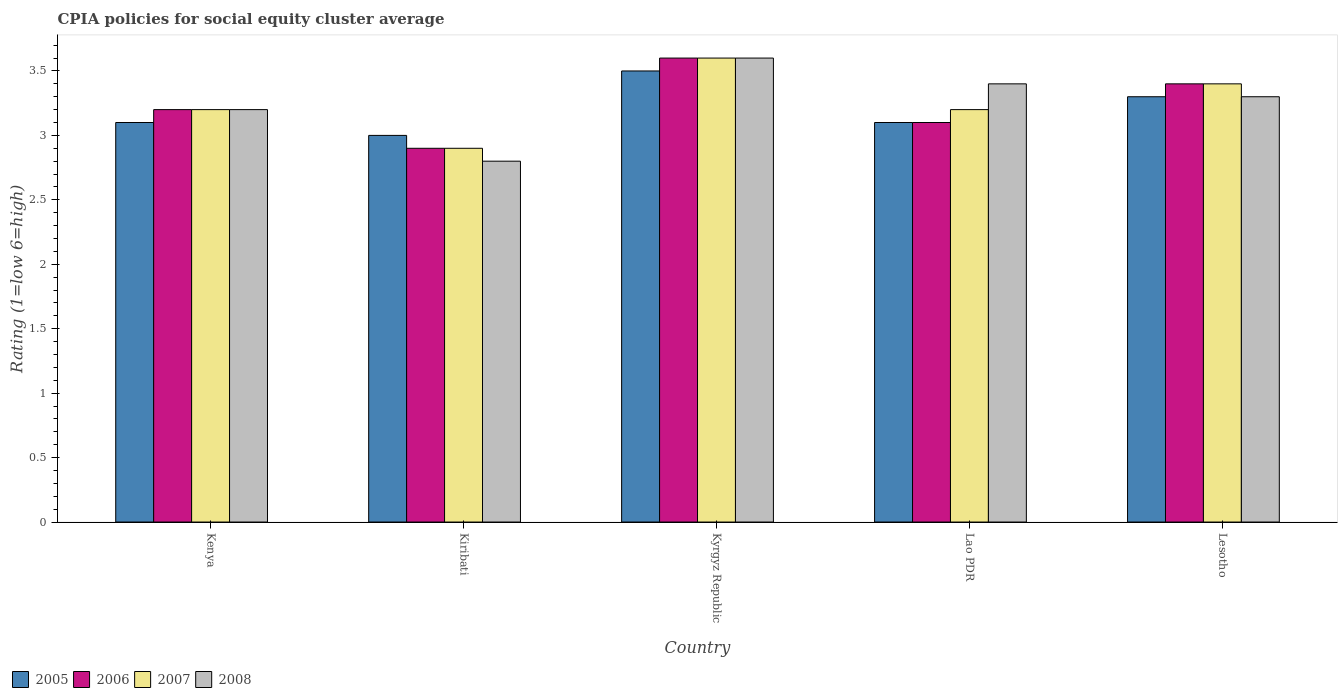How many groups of bars are there?
Make the answer very short. 5. How many bars are there on the 2nd tick from the left?
Provide a short and direct response. 4. How many bars are there on the 2nd tick from the right?
Keep it short and to the point. 4. What is the label of the 4th group of bars from the left?
Provide a short and direct response. Lao PDR. Across all countries, what is the maximum CPIA rating in 2008?
Make the answer very short. 3.6. In which country was the CPIA rating in 2007 maximum?
Provide a short and direct response. Kyrgyz Republic. In which country was the CPIA rating in 2007 minimum?
Provide a short and direct response. Kiribati. What is the difference between the CPIA rating in 2006 in Kiribati and that in Lesotho?
Your response must be concise. -0.5. What is the difference between the CPIA rating in 2005 in Kiribati and the CPIA rating in 2008 in Kenya?
Provide a succinct answer. -0.2. What is the average CPIA rating in 2006 per country?
Your answer should be compact. 3.24. What is the difference between the CPIA rating of/in 2007 and CPIA rating of/in 2008 in Lao PDR?
Provide a succinct answer. -0.2. In how many countries, is the CPIA rating in 2008 greater than 3.5?
Provide a short and direct response. 1. What is the ratio of the CPIA rating in 2007 in Kiribati to that in Kyrgyz Republic?
Give a very brief answer. 0.81. Is the CPIA rating in 2006 in Kyrgyz Republic less than that in Lao PDR?
Ensure brevity in your answer.  No. What is the difference between the highest and the second highest CPIA rating in 2005?
Provide a short and direct response. -0.2. What is the difference between the highest and the lowest CPIA rating in 2007?
Your answer should be very brief. 0.7. In how many countries, is the CPIA rating in 2008 greater than the average CPIA rating in 2008 taken over all countries?
Ensure brevity in your answer.  3. Is the sum of the CPIA rating in 2007 in Kenya and Kiribati greater than the maximum CPIA rating in 2006 across all countries?
Provide a short and direct response. Yes. What does the 1st bar from the left in Lesotho represents?
Provide a succinct answer. 2005. Is it the case that in every country, the sum of the CPIA rating in 2008 and CPIA rating in 2005 is greater than the CPIA rating in 2006?
Keep it short and to the point. Yes. How many bars are there?
Offer a very short reply. 20. What is the difference between two consecutive major ticks on the Y-axis?
Keep it short and to the point. 0.5. What is the title of the graph?
Make the answer very short. CPIA policies for social equity cluster average. Does "1972" appear as one of the legend labels in the graph?
Offer a terse response. No. What is the label or title of the X-axis?
Your answer should be compact. Country. What is the Rating (1=low 6=high) in 2005 in Kenya?
Provide a short and direct response. 3.1. What is the Rating (1=low 6=high) in 2008 in Kenya?
Give a very brief answer. 3.2. What is the Rating (1=low 6=high) of 2007 in Kiribati?
Provide a short and direct response. 2.9. What is the Rating (1=low 6=high) of 2008 in Kiribati?
Keep it short and to the point. 2.8. What is the Rating (1=low 6=high) in 2005 in Kyrgyz Republic?
Provide a short and direct response. 3.5. What is the Rating (1=low 6=high) in 2007 in Kyrgyz Republic?
Your answer should be compact. 3.6. What is the Rating (1=low 6=high) in 2008 in Kyrgyz Republic?
Your answer should be compact. 3.6. What is the Rating (1=low 6=high) in 2005 in Lao PDR?
Offer a very short reply. 3.1. What is the Rating (1=low 6=high) of 2008 in Lao PDR?
Your response must be concise. 3.4. What is the Rating (1=low 6=high) of 2005 in Lesotho?
Your response must be concise. 3.3. What is the Rating (1=low 6=high) of 2006 in Lesotho?
Provide a short and direct response. 3.4. Across all countries, what is the maximum Rating (1=low 6=high) in 2005?
Your answer should be very brief. 3.5. Across all countries, what is the maximum Rating (1=low 6=high) in 2006?
Provide a succinct answer. 3.6. Across all countries, what is the maximum Rating (1=low 6=high) in 2007?
Provide a short and direct response. 3.6. Across all countries, what is the maximum Rating (1=low 6=high) of 2008?
Provide a succinct answer. 3.6. Across all countries, what is the minimum Rating (1=low 6=high) of 2006?
Offer a very short reply. 2.9. Across all countries, what is the minimum Rating (1=low 6=high) of 2007?
Make the answer very short. 2.9. Across all countries, what is the minimum Rating (1=low 6=high) of 2008?
Offer a very short reply. 2.8. What is the total Rating (1=low 6=high) of 2005 in the graph?
Make the answer very short. 16. What is the total Rating (1=low 6=high) in 2006 in the graph?
Your answer should be compact. 16.2. What is the difference between the Rating (1=low 6=high) in 2005 in Kenya and that in Kiribati?
Ensure brevity in your answer.  0.1. What is the difference between the Rating (1=low 6=high) of 2006 in Kenya and that in Kiribati?
Provide a succinct answer. 0.3. What is the difference between the Rating (1=low 6=high) of 2007 in Kenya and that in Kiribati?
Make the answer very short. 0.3. What is the difference between the Rating (1=low 6=high) in 2008 in Kenya and that in Kiribati?
Give a very brief answer. 0.4. What is the difference between the Rating (1=low 6=high) in 2005 in Kenya and that in Kyrgyz Republic?
Give a very brief answer. -0.4. What is the difference between the Rating (1=low 6=high) in 2007 in Kenya and that in Kyrgyz Republic?
Provide a short and direct response. -0.4. What is the difference between the Rating (1=low 6=high) of 2005 in Kenya and that in Lao PDR?
Keep it short and to the point. 0. What is the difference between the Rating (1=low 6=high) of 2007 in Kenya and that in Lao PDR?
Offer a very short reply. 0. What is the difference between the Rating (1=low 6=high) in 2005 in Kenya and that in Lesotho?
Your answer should be very brief. -0.2. What is the difference between the Rating (1=low 6=high) in 2008 in Kenya and that in Lesotho?
Your response must be concise. -0.1. What is the difference between the Rating (1=low 6=high) in 2005 in Kiribati and that in Kyrgyz Republic?
Your response must be concise. -0.5. What is the difference between the Rating (1=low 6=high) in 2007 in Kiribati and that in Kyrgyz Republic?
Provide a short and direct response. -0.7. What is the difference between the Rating (1=low 6=high) of 2008 in Kiribati and that in Kyrgyz Republic?
Provide a succinct answer. -0.8. What is the difference between the Rating (1=low 6=high) of 2007 in Kiribati and that in Lao PDR?
Keep it short and to the point. -0.3. What is the difference between the Rating (1=low 6=high) in 2005 in Kiribati and that in Lesotho?
Ensure brevity in your answer.  -0.3. What is the difference between the Rating (1=low 6=high) of 2008 in Kiribati and that in Lesotho?
Offer a very short reply. -0.5. What is the difference between the Rating (1=low 6=high) of 2008 in Kyrgyz Republic and that in Lao PDR?
Your answer should be very brief. 0.2. What is the difference between the Rating (1=low 6=high) in 2005 in Kyrgyz Republic and that in Lesotho?
Provide a succinct answer. 0.2. What is the difference between the Rating (1=low 6=high) of 2007 in Kyrgyz Republic and that in Lesotho?
Your response must be concise. 0.2. What is the difference between the Rating (1=low 6=high) of 2005 in Lao PDR and that in Lesotho?
Provide a short and direct response. -0.2. What is the difference between the Rating (1=low 6=high) in 2006 in Lao PDR and that in Lesotho?
Ensure brevity in your answer.  -0.3. What is the difference between the Rating (1=low 6=high) in 2007 in Lao PDR and that in Lesotho?
Offer a very short reply. -0.2. What is the difference between the Rating (1=low 6=high) in 2008 in Lao PDR and that in Lesotho?
Keep it short and to the point. 0.1. What is the difference between the Rating (1=low 6=high) in 2005 in Kenya and the Rating (1=low 6=high) in 2006 in Kiribati?
Your answer should be very brief. 0.2. What is the difference between the Rating (1=low 6=high) of 2005 in Kenya and the Rating (1=low 6=high) of 2006 in Kyrgyz Republic?
Ensure brevity in your answer.  -0.5. What is the difference between the Rating (1=low 6=high) in 2005 in Kenya and the Rating (1=low 6=high) in 2007 in Kyrgyz Republic?
Give a very brief answer. -0.5. What is the difference between the Rating (1=low 6=high) in 2005 in Kenya and the Rating (1=low 6=high) in 2008 in Kyrgyz Republic?
Offer a very short reply. -0.5. What is the difference between the Rating (1=low 6=high) of 2006 in Kenya and the Rating (1=low 6=high) of 2008 in Kyrgyz Republic?
Keep it short and to the point. -0.4. What is the difference between the Rating (1=low 6=high) in 2005 in Kenya and the Rating (1=low 6=high) in 2006 in Lao PDR?
Offer a very short reply. 0. What is the difference between the Rating (1=low 6=high) in 2005 in Kenya and the Rating (1=low 6=high) in 2007 in Lao PDR?
Offer a terse response. -0.1. What is the difference between the Rating (1=low 6=high) of 2006 in Kenya and the Rating (1=low 6=high) of 2007 in Lao PDR?
Give a very brief answer. 0. What is the difference between the Rating (1=low 6=high) of 2005 in Kenya and the Rating (1=low 6=high) of 2007 in Lesotho?
Offer a very short reply. -0.3. What is the difference between the Rating (1=low 6=high) in 2005 in Kenya and the Rating (1=low 6=high) in 2008 in Lesotho?
Your answer should be compact. -0.2. What is the difference between the Rating (1=low 6=high) in 2007 in Kenya and the Rating (1=low 6=high) in 2008 in Lesotho?
Keep it short and to the point. -0.1. What is the difference between the Rating (1=low 6=high) in 2006 in Kiribati and the Rating (1=low 6=high) in 2007 in Kyrgyz Republic?
Provide a short and direct response. -0.7. What is the difference between the Rating (1=low 6=high) in 2007 in Kiribati and the Rating (1=low 6=high) in 2008 in Kyrgyz Republic?
Keep it short and to the point. -0.7. What is the difference between the Rating (1=low 6=high) of 2005 in Kiribati and the Rating (1=low 6=high) of 2006 in Lao PDR?
Offer a very short reply. -0.1. What is the difference between the Rating (1=low 6=high) in 2006 in Kiribati and the Rating (1=low 6=high) in 2007 in Lao PDR?
Ensure brevity in your answer.  -0.3. What is the difference between the Rating (1=low 6=high) in 2006 in Kiribati and the Rating (1=low 6=high) in 2008 in Lao PDR?
Offer a terse response. -0.5. What is the difference between the Rating (1=low 6=high) of 2007 in Kiribati and the Rating (1=low 6=high) of 2008 in Lao PDR?
Provide a succinct answer. -0.5. What is the difference between the Rating (1=low 6=high) in 2005 in Kiribati and the Rating (1=low 6=high) in 2008 in Lesotho?
Provide a short and direct response. -0.3. What is the difference between the Rating (1=low 6=high) of 2006 in Kiribati and the Rating (1=low 6=high) of 2007 in Lesotho?
Offer a terse response. -0.5. What is the difference between the Rating (1=low 6=high) of 2006 in Kiribati and the Rating (1=low 6=high) of 2008 in Lesotho?
Provide a succinct answer. -0.4. What is the difference between the Rating (1=low 6=high) in 2005 in Kyrgyz Republic and the Rating (1=low 6=high) in 2006 in Lao PDR?
Provide a short and direct response. 0.4. What is the difference between the Rating (1=low 6=high) of 2005 in Kyrgyz Republic and the Rating (1=low 6=high) of 2007 in Lao PDR?
Make the answer very short. 0.3. What is the difference between the Rating (1=low 6=high) of 2006 in Kyrgyz Republic and the Rating (1=low 6=high) of 2007 in Lao PDR?
Make the answer very short. 0.4. What is the difference between the Rating (1=low 6=high) in 2006 in Kyrgyz Republic and the Rating (1=low 6=high) in 2008 in Lao PDR?
Ensure brevity in your answer.  0.2. What is the difference between the Rating (1=low 6=high) in 2007 in Kyrgyz Republic and the Rating (1=low 6=high) in 2008 in Lao PDR?
Your answer should be compact. 0.2. What is the difference between the Rating (1=low 6=high) of 2005 in Kyrgyz Republic and the Rating (1=low 6=high) of 2006 in Lesotho?
Ensure brevity in your answer.  0.1. What is the difference between the Rating (1=low 6=high) of 2005 in Kyrgyz Republic and the Rating (1=low 6=high) of 2007 in Lesotho?
Ensure brevity in your answer.  0.1. What is the difference between the Rating (1=low 6=high) in 2006 in Kyrgyz Republic and the Rating (1=low 6=high) in 2007 in Lesotho?
Your response must be concise. 0.2. What is the difference between the Rating (1=low 6=high) of 2005 in Lao PDR and the Rating (1=low 6=high) of 2006 in Lesotho?
Provide a succinct answer. -0.3. What is the difference between the Rating (1=low 6=high) in 2005 in Lao PDR and the Rating (1=low 6=high) in 2008 in Lesotho?
Give a very brief answer. -0.2. What is the difference between the Rating (1=low 6=high) of 2006 in Lao PDR and the Rating (1=low 6=high) of 2007 in Lesotho?
Give a very brief answer. -0.3. What is the difference between the Rating (1=low 6=high) of 2006 in Lao PDR and the Rating (1=low 6=high) of 2008 in Lesotho?
Provide a succinct answer. -0.2. What is the average Rating (1=low 6=high) in 2005 per country?
Offer a very short reply. 3.2. What is the average Rating (1=low 6=high) of 2006 per country?
Provide a short and direct response. 3.24. What is the average Rating (1=low 6=high) of 2007 per country?
Make the answer very short. 3.26. What is the average Rating (1=low 6=high) of 2008 per country?
Your response must be concise. 3.26. What is the difference between the Rating (1=low 6=high) in 2005 and Rating (1=low 6=high) in 2006 in Kenya?
Provide a short and direct response. -0.1. What is the difference between the Rating (1=low 6=high) in 2005 and Rating (1=low 6=high) in 2008 in Kenya?
Give a very brief answer. -0.1. What is the difference between the Rating (1=low 6=high) of 2006 and Rating (1=low 6=high) of 2007 in Kenya?
Provide a short and direct response. 0. What is the difference between the Rating (1=low 6=high) of 2005 and Rating (1=low 6=high) of 2006 in Kiribati?
Your response must be concise. 0.1. What is the difference between the Rating (1=low 6=high) in 2005 and Rating (1=low 6=high) in 2008 in Kiribati?
Your response must be concise. 0.2. What is the difference between the Rating (1=low 6=high) in 2005 and Rating (1=low 6=high) in 2006 in Kyrgyz Republic?
Your answer should be very brief. -0.1. What is the difference between the Rating (1=low 6=high) of 2005 and Rating (1=low 6=high) of 2008 in Kyrgyz Republic?
Give a very brief answer. -0.1. What is the difference between the Rating (1=low 6=high) of 2006 and Rating (1=low 6=high) of 2007 in Kyrgyz Republic?
Offer a terse response. 0. What is the difference between the Rating (1=low 6=high) of 2006 and Rating (1=low 6=high) of 2007 in Lao PDR?
Your answer should be compact. -0.1. What is the difference between the Rating (1=low 6=high) of 2006 and Rating (1=low 6=high) of 2008 in Lao PDR?
Provide a short and direct response. -0.3. What is the difference between the Rating (1=low 6=high) of 2005 and Rating (1=low 6=high) of 2006 in Lesotho?
Offer a very short reply. -0.1. What is the difference between the Rating (1=low 6=high) of 2005 and Rating (1=low 6=high) of 2008 in Lesotho?
Offer a very short reply. 0. What is the difference between the Rating (1=low 6=high) in 2006 and Rating (1=low 6=high) in 2008 in Lesotho?
Provide a short and direct response. 0.1. What is the ratio of the Rating (1=low 6=high) in 2005 in Kenya to that in Kiribati?
Your answer should be very brief. 1.03. What is the ratio of the Rating (1=low 6=high) in 2006 in Kenya to that in Kiribati?
Your answer should be very brief. 1.1. What is the ratio of the Rating (1=low 6=high) of 2007 in Kenya to that in Kiribati?
Your answer should be compact. 1.1. What is the ratio of the Rating (1=low 6=high) of 2005 in Kenya to that in Kyrgyz Republic?
Your answer should be compact. 0.89. What is the ratio of the Rating (1=low 6=high) in 2006 in Kenya to that in Kyrgyz Republic?
Provide a succinct answer. 0.89. What is the ratio of the Rating (1=low 6=high) of 2006 in Kenya to that in Lao PDR?
Your answer should be compact. 1.03. What is the ratio of the Rating (1=low 6=high) in 2005 in Kenya to that in Lesotho?
Make the answer very short. 0.94. What is the ratio of the Rating (1=low 6=high) of 2006 in Kenya to that in Lesotho?
Offer a very short reply. 0.94. What is the ratio of the Rating (1=low 6=high) in 2008 in Kenya to that in Lesotho?
Provide a succinct answer. 0.97. What is the ratio of the Rating (1=low 6=high) of 2005 in Kiribati to that in Kyrgyz Republic?
Your answer should be compact. 0.86. What is the ratio of the Rating (1=low 6=high) in 2006 in Kiribati to that in Kyrgyz Republic?
Provide a short and direct response. 0.81. What is the ratio of the Rating (1=low 6=high) of 2007 in Kiribati to that in Kyrgyz Republic?
Keep it short and to the point. 0.81. What is the ratio of the Rating (1=low 6=high) of 2006 in Kiribati to that in Lao PDR?
Provide a short and direct response. 0.94. What is the ratio of the Rating (1=low 6=high) of 2007 in Kiribati to that in Lao PDR?
Your answer should be compact. 0.91. What is the ratio of the Rating (1=low 6=high) of 2008 in Kiribati to that in Lao PDR?
Your answer should be very brief. 0.82. What is the ratio of the Rating (1=low 6=high) of 2006 in Kiribati to that in Lesotho?
Provide a short and direct response. 0.85. What is the ratio of the Rating (1=low 6=high) of 2007 in Kiribati to that in Lesotho?
Offer a terse response. 0.85. What is the ratio of the Rating (1=low 6=high) of 2008 in Kiribati to that in Lesotho?
Ensure brevity in your answer.  0.85. What is the ratio of the Rating (1=low 6=high) of 2005 in Kyrgyz Republic to that in Lao PDR?
Provide a short and direct response. 1.13. What is the ratio of the Rating (1=low 6=high) in 2006 in Kyrgyz Republic to that in Lao PDR?
Give a very brief answer. 1.16. What is the ratio of the Rating (1=low 6=high) of 2007 in Kyrgyz Republic to that in Lao PDR?
Give a very brief answer. 1.12. What is the ratio of the Rating (1=low 6=high) in 2008 in Kyrgyz Republic to that in Lao PDR?
Provide a short and direct response. 1.06. What is the ratio of the Rating (1=low 6=high) of 2005 in Kyrgyz Republic to that in Lesotho?
Keep it short and to the point. 1.06. What is the ratio of the Rating (1=low 6=high) in 2006 in Kyrgyz Republic to that in Lesotho?
Make the answer very short. 1.06. What is the ratio of the Rating (1=low 6=high) in 2007 in Kyrgyz Republic to that in Lesotho?
Your response must be concise. 1.06. What is the ratio of the Rating (1=low 6=high) in 2005 in Lao PDR to that in Lesotho?
Make the answer very short. 0.94. What is the ratio of the Rating (1=low 6=high) of 2006 in Lao PDR to that in Lesotho?
Give a very brief answer. 0.91. What is the ratio of the Rating (1=low 6=high) of 2008 in Lao PDR to that in Lesotho?
Offer a very short reply. 1.03. What is the difference between the highest and the second highest Rating (1=low 6=high) of 2006?
Ensure brevity in your answer.  0.2. What is the difference between the highest and the second highest Rating (1=low 6=high) in 2007?
Your response must be concise. 0.2. What is the difference between the highest and the second highest Rating (1=low 6=high) in 2008?
Make the answer very short. 0.2. What is the difference between the highest and the lowest Rating (1=low 6=high) of 2005?
Provide a succinct answer. 0.5. What is the difference between the highest and the lowest Rating (1=low 6=high) in 2006?
Provide a short and direct response. 0.7. What is the difference between the highest and the lowest Rating (1=low 6=high) in 2007?
Ensure brevity in your answer.  0.7. 